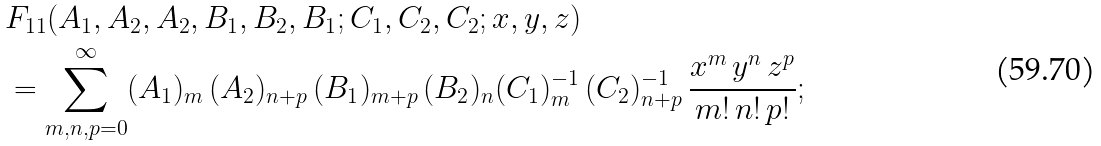Convert formula to latex. <formula><loc_0><loc_0><loc_500><loc_500>& F _ { 1 1 } ( A _ { 1 } , A _ { 2 } , A _ { 2 } , B _ { 1 } , B _ { 2 } , B _ { 1 } ; C _ { 1 } , C _ { 2 } , C _ { 2 } ; x , y , z ) \\ & = \sum _ { m , n , p = 0 } ^ { \infty } ( A _ { 1 } ) _ { m } \, ( A _ { 2 } ) _ { n + p } \, ( B _ { 1 } ) _ { m + p } \, ( B _ { 2 } ) _ { n } ( C _ { 1 } ) _ { m } ^ { - 1 } \, ( C _ { 2 } ) ^ { - 1 } _ { n + p } \, \frac { x ^ { m } \, y ^ { n } \, z ^ { p } } { m ! \, n ! \, p ! } ;</formula> 